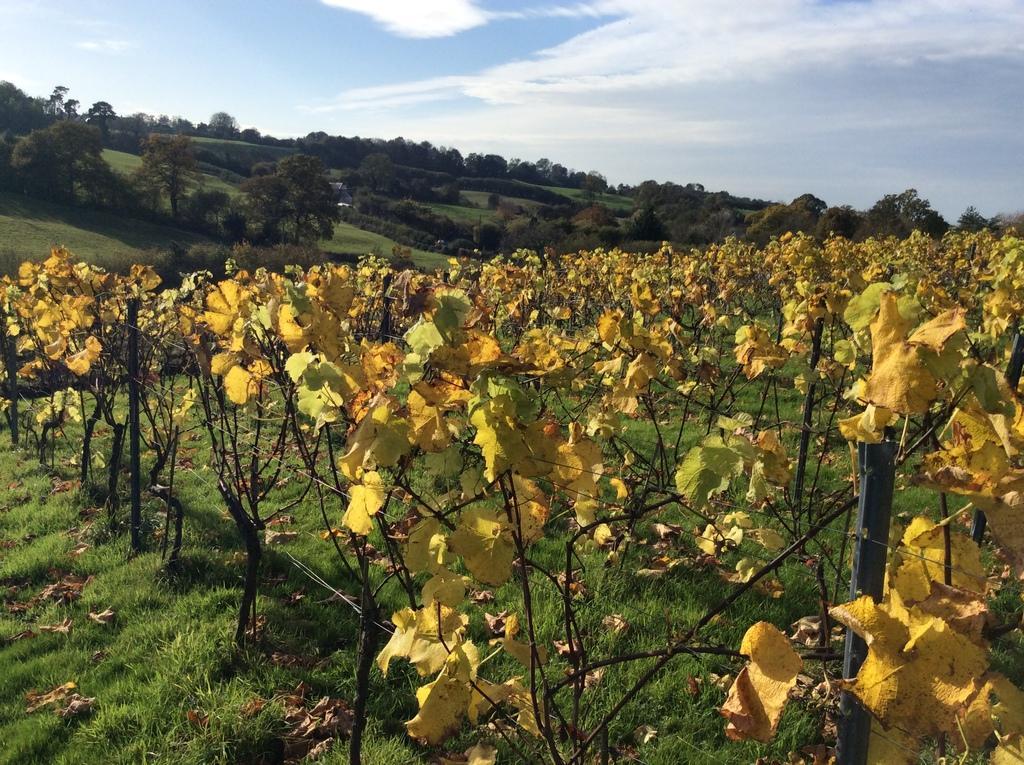Please provide a concise description of this image. In the foreground of the picture there are plants, grass and dry leaves. In the background we can see trees and grasslands. At the top there is sky. 